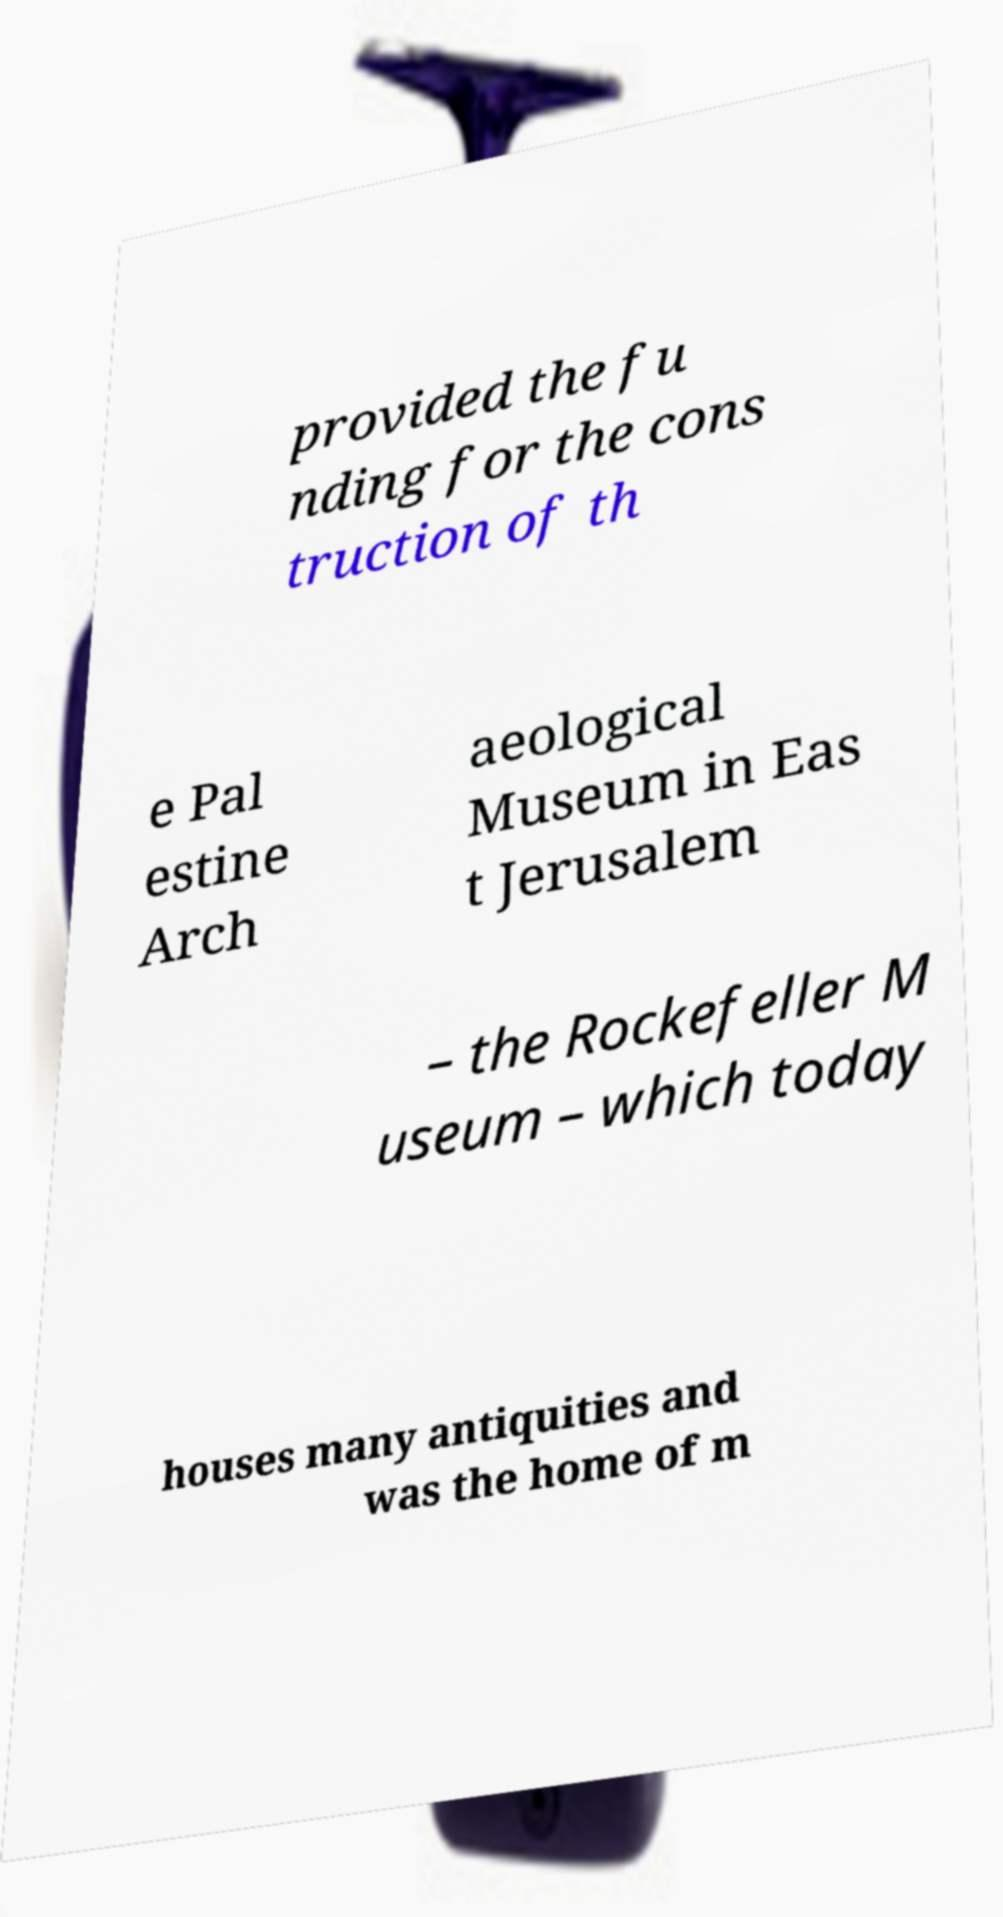There's text embedded in this image that I need extracted. Can you transcribe it verbatim? provided the fu nding for the cons truction of th e Pal estine Arch aeological Museum in Eas t Jerusalem – the Rockefeller M useum – which today houses many antiquities and was the home of m 